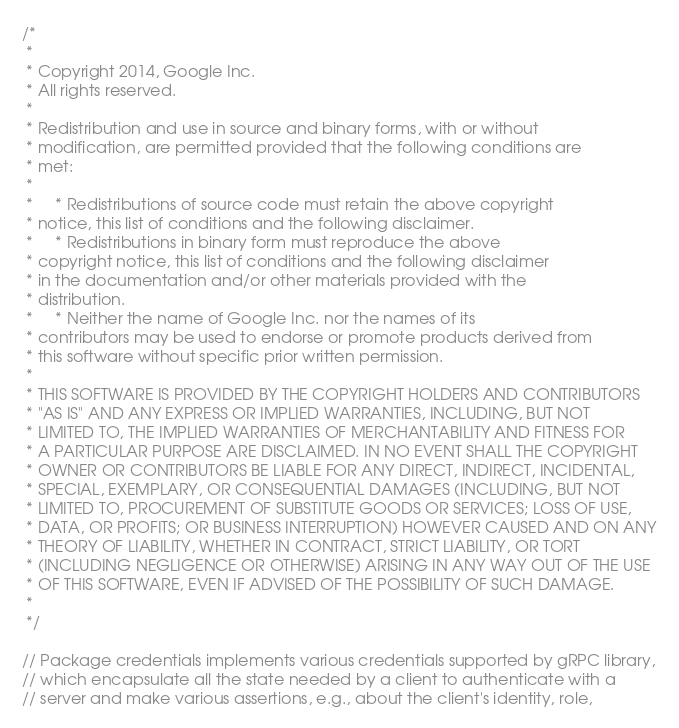<code> <loc_0><loc_0><loc_500><loc_500><_Go_>/*
 *
 * Copyright 2014, Google Inc.
 * All rights reserved.
 *
 * Redistribution and use in source and binary forms, with or without
 * modification, are permitted provided that the following conditions are
 * met:
 *
 *     * Redistributions of source code must retain the above copyright
 * notice, this list of conditions and the following disclaimer.
 *     * Redistributions in binary form must reproduce the above
 * copyright notice, this list of conditions and the following disclaimer
 * in the documentation and/or other materials provided with the
 * distribution.
 *     * Neither the name of Google Inc. nor the names of its
 * contributors may be used to endorse or promote products derived from
 * this software without specific prior written permission.
 *
 * THIS SOFTWARE IS PROVIDED BY THE COPYRIGHT HOLDERS AND CONTRIBUTORS
 * "AS IS" AND ANY EXPRESS OR IMPLIED WARRANTIES, INCLUDING, BUT NOT
 * LIMITED TO, THE IMPLIED WARRANTIES OF MERCHANTABILITY AND FITNESS FOR
 * A PARTICULAR PURPOSE ARE DISCLAIMED. IN NO EVENT SHALL THE COPYRIGHT
 * OWNER OR CONTRIBUTORS BE LIABLE FOR ANY DIRECT, INDIRECT, INCIDENTAL,
 * SPECIAL, EXEMPLARY, OR CONSEQUENTIAL DAMAGES (INCLUDING, BUT NOT
 * LIMITED TO, PROCUREMENT OF SUBSTITUTE GOODS OR SERVICES; LOSS OF USE,
 * DATA, OR PROFITS; OR BUSINESS INTERRUPTION) HOWEVER CAUSED AND ON ANY
 * THEORY OF LIABILITY, WHETHER IN CONTRACT, STRICT LIABILITY, OR TORT
 * (INCLUDING NEGLIGENCE OR OTHERWISE) ARISING IN ANY WAY OUT OF THE USE
 * OF THIS SOFTWARE, EVEN IF ADVISED OF THE POSSIBILITY OF SUCH DAMAGE.
 *
 */

// Package credentials implements various credentials supported by gRPC library,
// which encapsulate all the state needed by a client to authenticate with a
// server and make various assertions, e.g., about the client's identity, role,</code> 